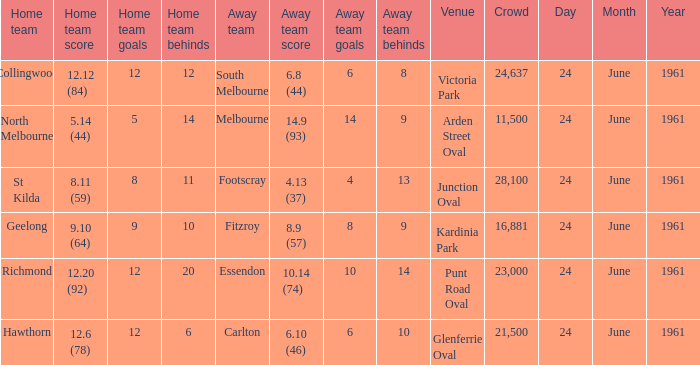Who was the home team that scored 12.6 (78)? Hawthorn. Could you help me parse every detail presented in this table? {'header': ['Home team', 'Home team score', 'Home team goals', 'Home team behinds', 'Away team', 'Away team score', 'Away team goals', 'Away team behinds', 'Venue', 'Crowd', 'Day', 'Month', 'Year'], 'rows': [['Collingwood', '12.12 (84)', '12', '12', 'South Melbourne', '6.8 (44)', '6', '8', 'Victoria Park', '24,637', '24', 'June', '1961'], ['North Melbourne', '5.14 (44)', '5', '14', 'Melbourne', '14.9 (93)', '14', '9', 'Arden Street Oval', '11,500', '24', 'June', '1961'], ['St Kilda', '8.11 (59)', '8', '11', 'Footscray', '4.13 (37)', '4', '13', 'Junction Oval', '28,100', '24', 'June', '1961'], ['Geelong', '9.10 (64)', '9', '10', 'Fitzroy', '8.9 (57)', '8', '9', 'Kardinia Park', '16,881', '24', 'June', '1961'], ['Richmond', '12.20 (92)', '12', '20', 'Essendon', '10.14 (74)', '10', '14', 'Punt Road Oval', '23,000', '24', 'June', '1961'], ['Hawthorn', '12.6 (78)', '12', '6', 'Carlton', '6.10 (46)', '6', '10', 'Glenferrie Oval', '21,500', '24', 'June', '1961']]} 